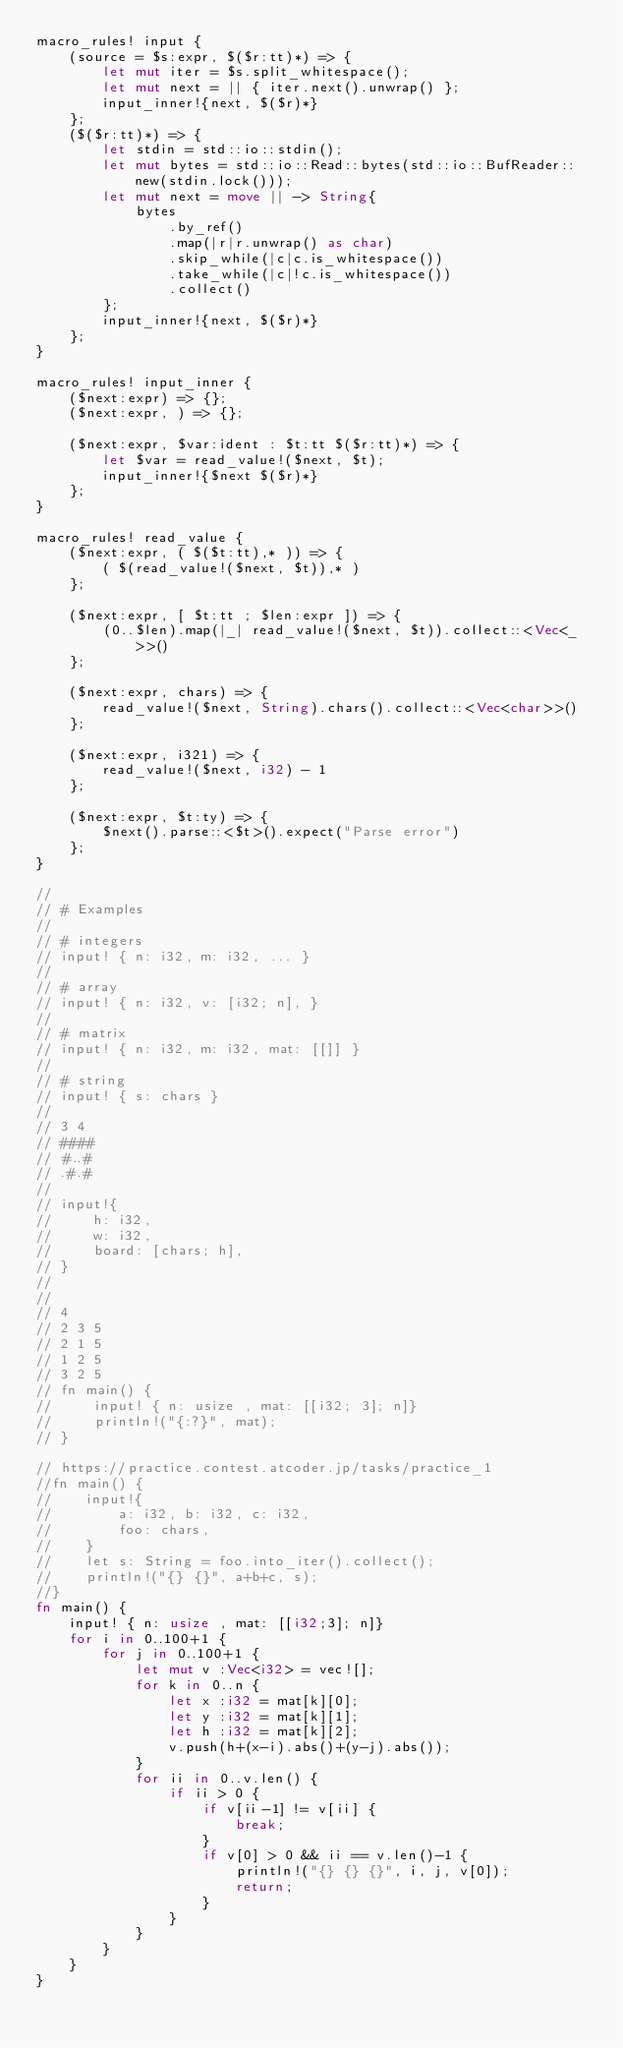<code> <loc_0><loc_0><loc_500><loc_500><_Rust_>macro_rules! input {
    (source = $s:expr, $($r:tt)*) => {
        let mut iter = $s.split_whitespace();
        let mut next = || { iter.next().unwrap() };
        input_inner!{next, $($r)*}
    };
    ($($r:tt)*) => {
        let stdin = std::io::stdin();
        let mut bytes = std::io::Read::bytes(std::io::BufReader::new(stdin.lock()));
        let mut next = move || -> String{
            bytes
                .by_ref()
                .map(|r|r.unwrap() as char)
                .skip_while(|c|c.is_whitespace())
                .take_while(|c|!c.is_whitespace())
                .collect()
        };
        input_inner!{next, $($r)*}
    };
}

macro_rules! input_inner {
    ($next:expr) => {};
    ($next:expr, ) => {};

    ($next:expr, $var:ident : $t:tt $($r:tt)*) => {
        let $var = read_value!($next, $t);
        input_inner!{$next $($r)*}
    };
}

macro_rules! read_value {
    ($next:expr, ( $($t:tt),* )) => {
        ( $(read_value!($next, $t)),* )
    };

    ($next:expr, [ $t:tt ; $len:expr ]) => {
        (0..$len).map(|_| read_value!($next, $t)).collect::<Vec<_>>()
    };

    ($next:expr, chars) => {
        read_value!($next, String).chars().collect::<Vec<char>>()
    };

    ($next:expr, i321) => {
        read_value!($next, i32) - 1
    };

    ($next:expr, $t:ty) => {
        $next().parse::<$t>().expect("Parse error")
    };
}

//
// # Examples
//
// # integers
// input! { n: i32, m: i32, ... }
//
// # array
// input! { n: i32, v: [i32; n], }
//
// # matrix
// input! { n: i32, m: i32, mat: [[]] }
// 
// # string
// input! { s: chars }
//
// 3 4
// ####
// #..#
// .#.#
//
// input!{
//     h: i32,
//     w: i32,
//     board: [chars; h],
// }
// 
// 
// 4
// 2 3 5
// 2 1 5
// 1 2 5
// 3 2 5
// fn main() {
//     input! { n: usize , mat: [[i32; 3]; n]}
//     println!("{:?}", mat);
// }

// https://practice.contest.atcoder.jp/tasks/practice_1
//fn main() {
//    input!{
//        a: i32, b: i32, c: i32,
//        foo: chars,
//    }
//    let s: String = foo.into_iter().collect();
//    println!("{} {}", a+b+c, s);
//}
fn main() {
    input! { n: usize , mat: [[i32;3]; n]}
    for i in 0..100+1 {
        for j in 0..100+1 {
            let mut v :Vec<i32> = vec![];
            for k in 0..n {
                let x :i32 = mat[k][0];
                let y :i32 = mat[k][1];
                let h :i32 = mat[k][2];
                v.push(h+(x-i).abs()+(y-j).abs());
            }
            for ii in 0..v.len() {
                if ii > 0 {
                    if v[ii-1] != v[ii] {
                        break;
                    }
                    if v[0] > 0 && ii == v.len()-1 {
                        println!("{} {} {}", i, j, v[0]);
                        return;
                    }
                }
            }
        }
    }
}</code> 